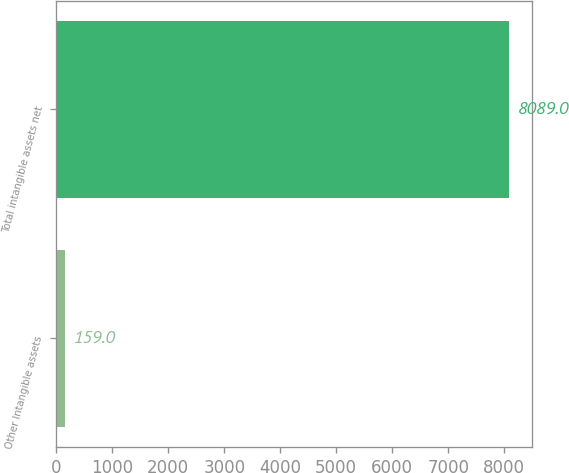<chart> <loc_0><loc_0><loc_500><loc_500><bar_chart><fcel>Other Intangible assets<fcel>Total intangible assets net<nl><fcel>159<fcel>8089<nl></chart> 